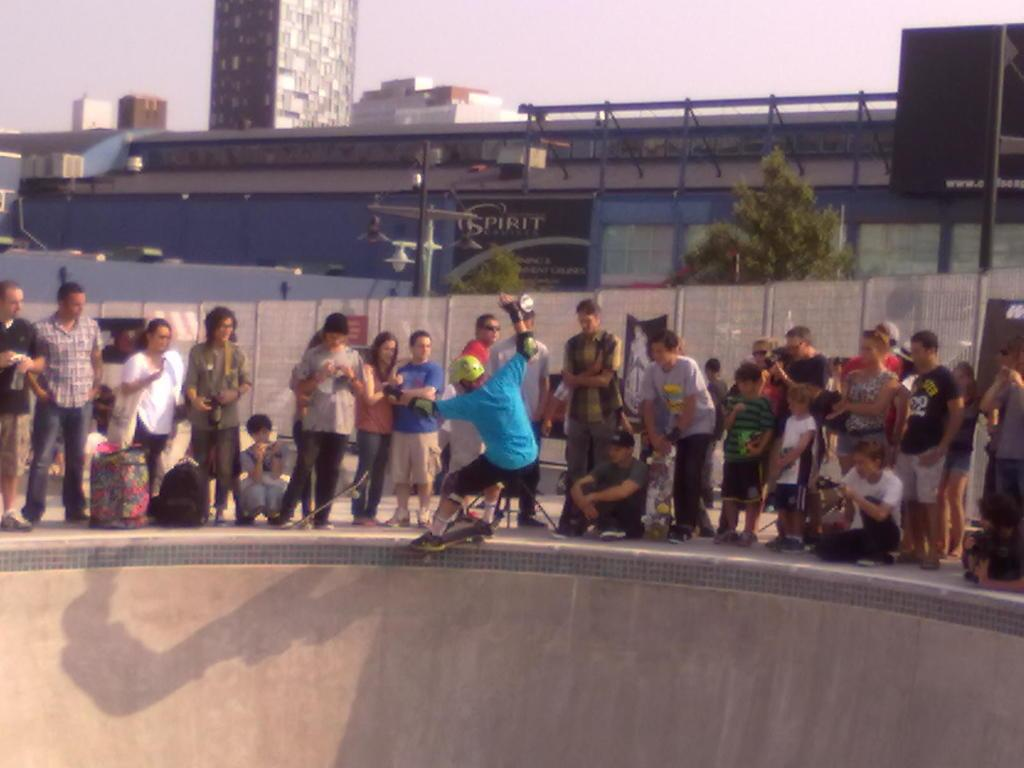How many people are present in the image? There are many people in the image. What activity is one of the people engaged in? A person is skating on the surface. What can be seen in the background of the image? There are trees and buildings in the background of the image. What type of pain is the person experiencing while skating in the image? There is no indication in the image that the person is experiencing any pain while skating. 